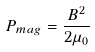Convert formula to latex. <formula><loc_0><loc_0><loc_500><loc_500>P _ { m a g } = { \frac { B ^ { 2 } } { 2 \mu _ { 0 } } }</formula> 